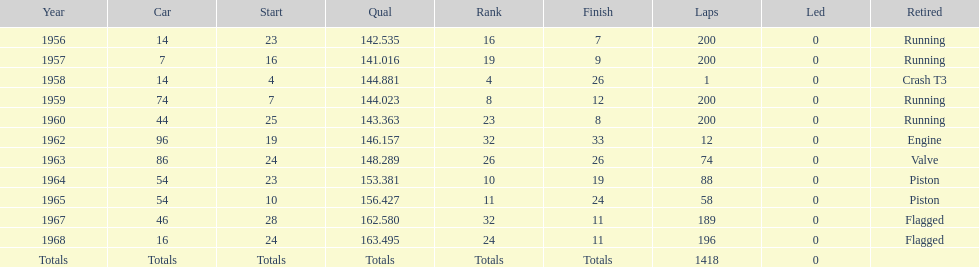In which year did he possess a car with the same number as the one in 1964? 1965. 